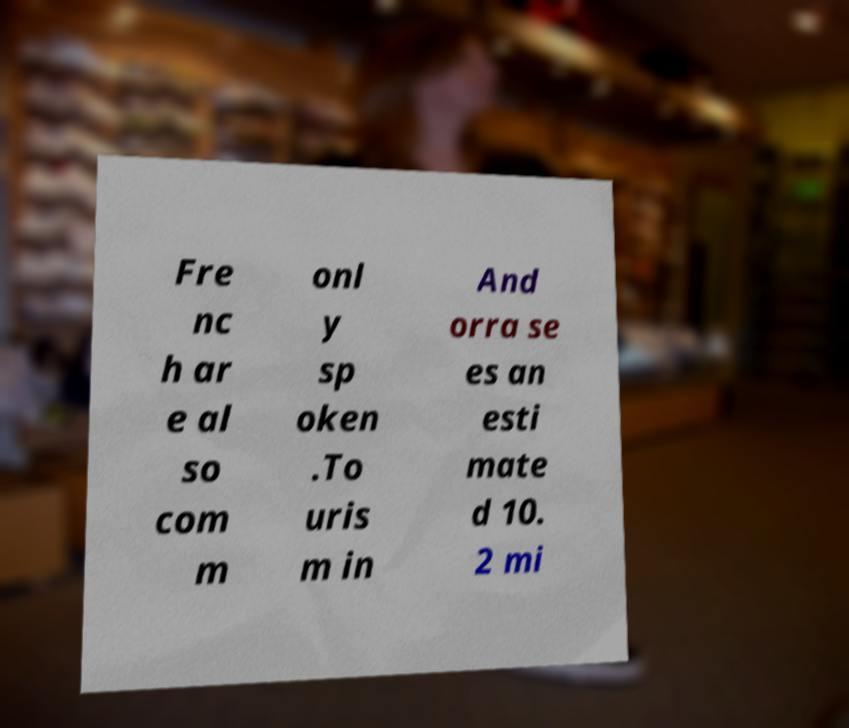Could you extract and type out the text from this image? Fre nc h ar e al so com m onl y sp oken .To uris m in And orra se es an esti mate d 10. 2 mi 